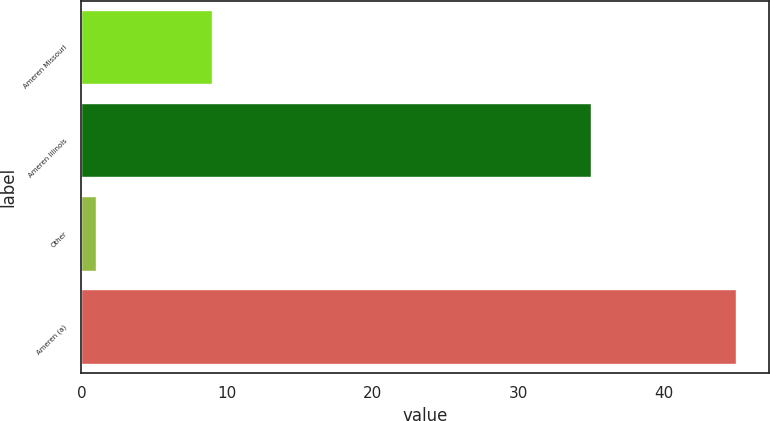<chart> <loc_0><loc_0><loc_500><loc_500><bar_chart><fcel>Ameren Missouri<fcel>Ameren Illinois<fcel>Other<fcel>Ameren (a)<nl><fcel>9<fcel>35<fcel>1<fcel>45<nl></chart> 